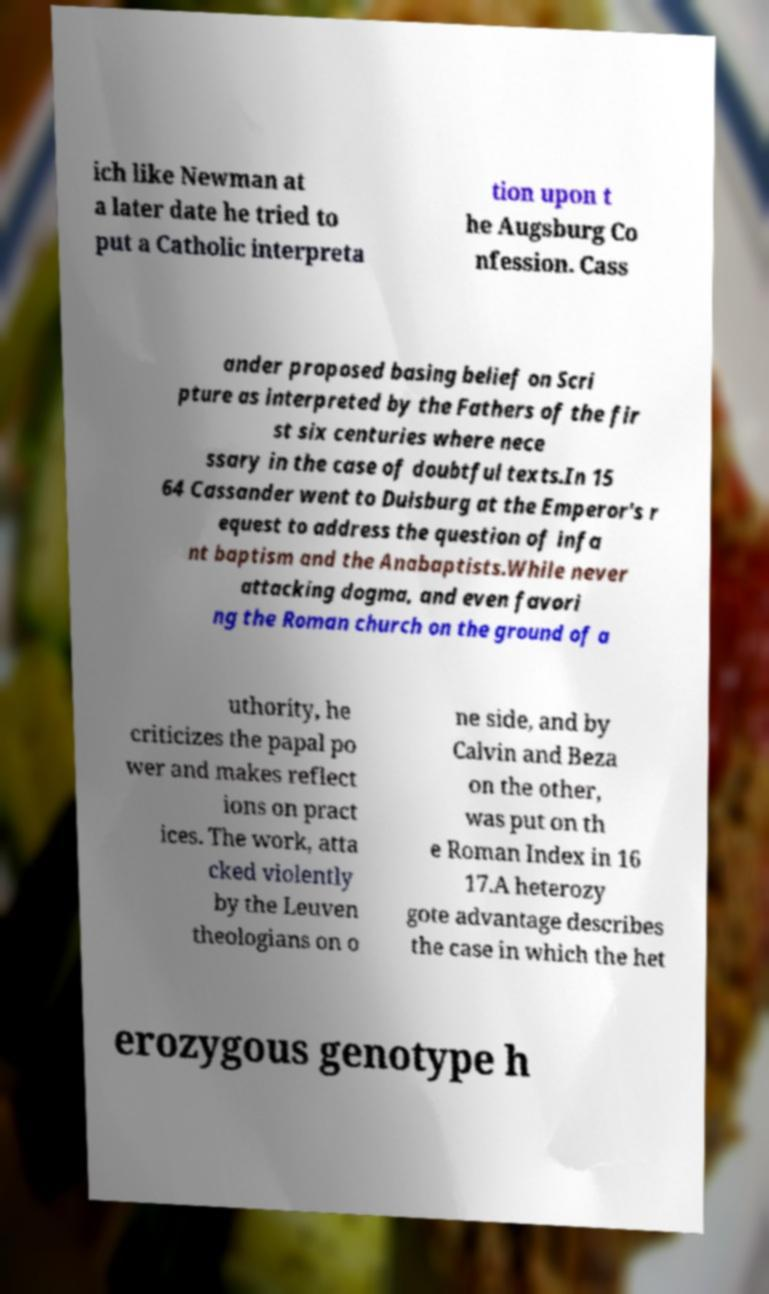For documentation purposes, I need the text within this image transcribed. Could you provide that? ich like Newman at a later date he tried to put a Catholic interpreta tion upon t he Augsburg Co nfession. Cass ander proposed basing belief on Scri pture as interpreted by the Fathers of the fir st six centuries where nece ssary in the case of doubtful texts.In 15 64 Cassander went to Duisburg at the Emperor's r equest to address the question of infa nt baptism and the Anabaptists.While never attacking dogma, and even favori ng the Roman church on the ground of a uthority, he criticizes the papal po wer and makes reflect ions on pract ices. The work, atta cked violently by the Leuven theologians on o ne side, and by Calvin and Beza on the other, was put on th e Roman Index in 16 17.A heterozy gote advantage describes the case in which the het erozygous genotype h 